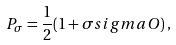Convert formula to latex. <formula><loc_0><loc_0><loc_500><loc_500>P _ { \sigma } = \frac { 1 } { 2 } ( 1 + \sigma s i g m a O ) \, ,</formula> 